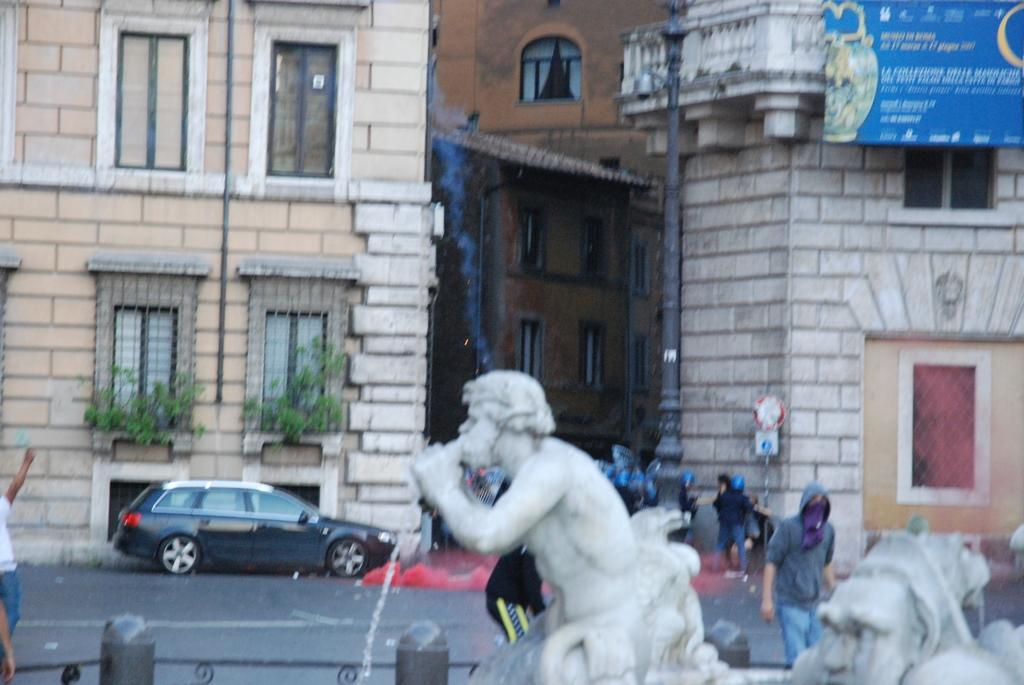What type of artwork can be seen in the image? There are sculptures in the image. Are there any people present in the image? Yes, there are people in the image. What type of structure is visible in the image? There is a building in the image. What feature of the building can be observed? The building has windows. What other elements can be seen in the image? There are plants and a board in the image. Is there any transportation visible in the image? Yes, there is a car in the image. Can you hear the horn of the car in the image? There is no sound present in the image, so it is not possible to hear the horn of the car. What type of agreement is being discussed in the image? There is no indication of any agreement being discussed in the image. 